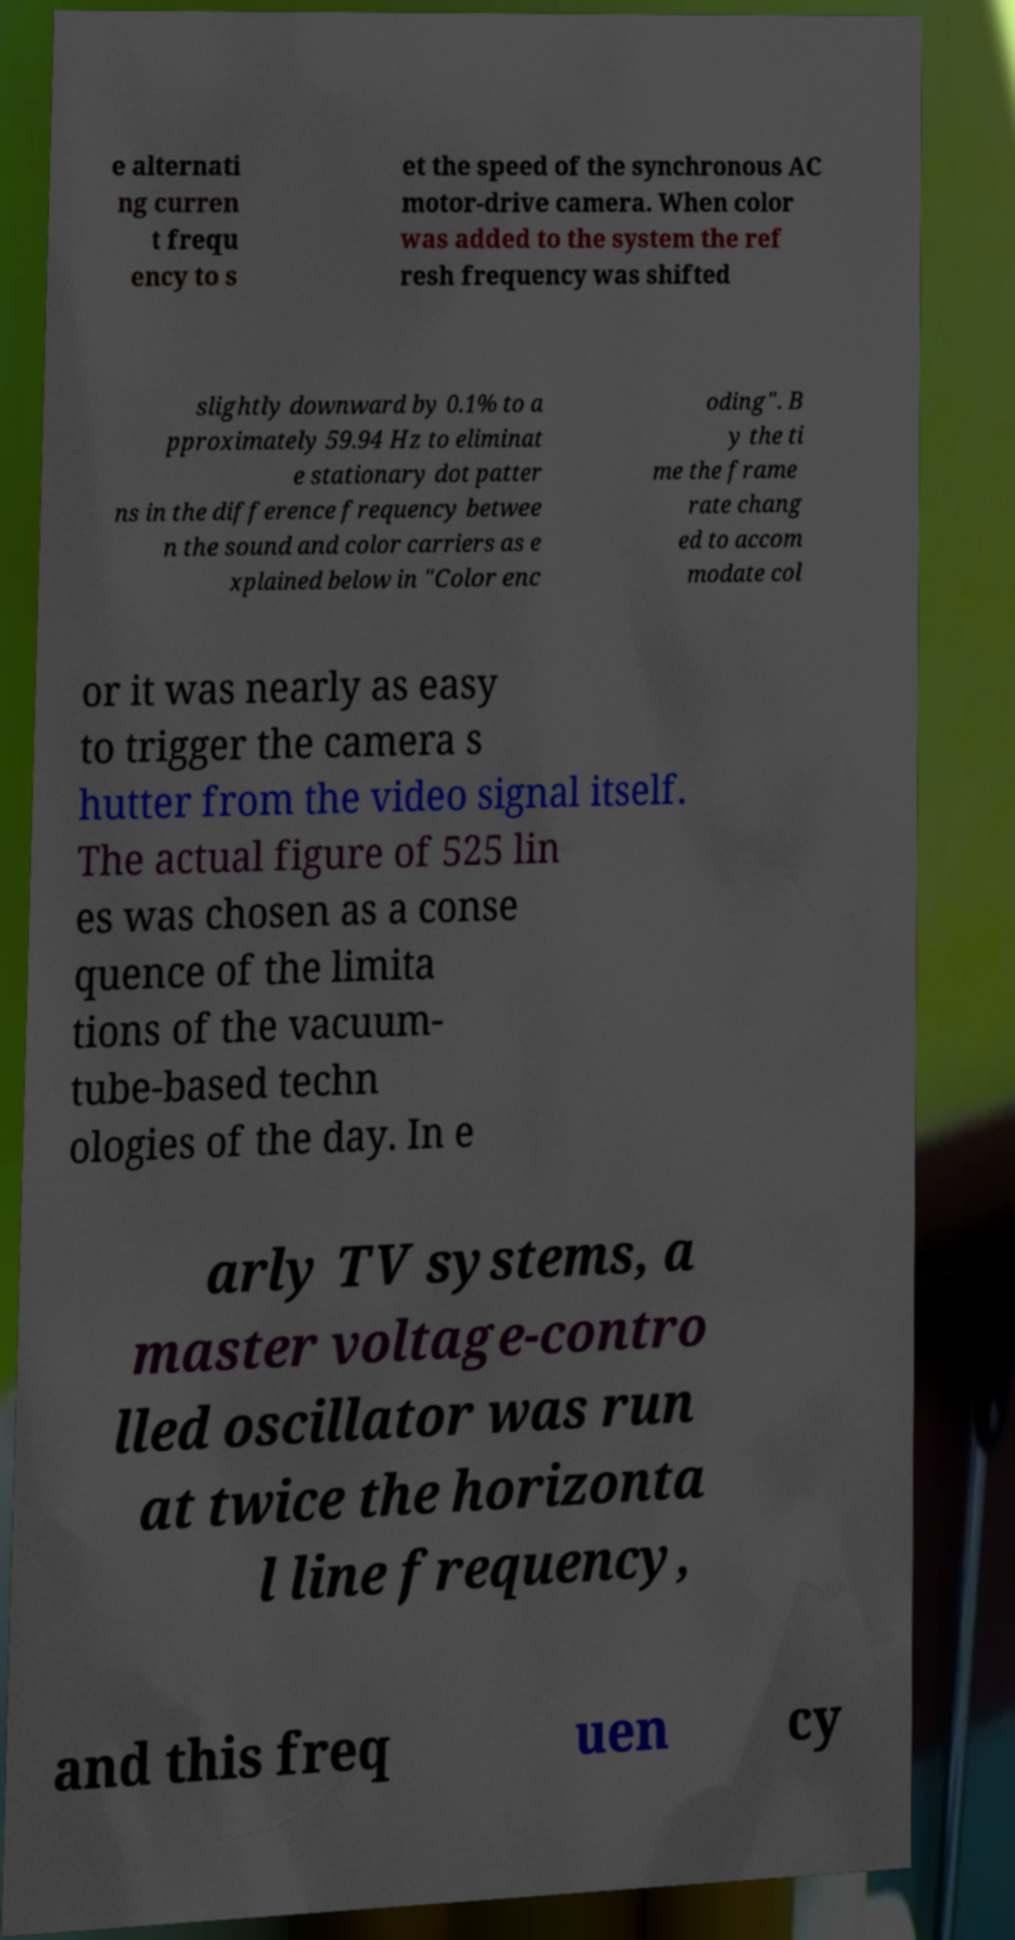Can you read and provide the text displayed in the image?This photo seems to have some interesting text. Can you extract and type it out for me? e alternati ng curren t frequ ency to s et the speed of the synchronous AC motor-drive camera. When color was added to the system the ref resh frequency was shifted slightly downward by 0.1% to a pproximately 59.94 Hz to eliminat e stationary dot patter ns in the difference frequency betwee n the sound and color carriers as e xplained below in "Color enc oding". B y the ti me the frame rate chang ed to accom modate col or it was nearly as easy to trigger the camera s hutter from the video signal itself. The actual figure of 525 lin es was chosen as a conse quence of the limita tions of the vacuum- tube-based techn ologies of the day. In e arly TV systems, a master voltage-contro lled oscillator was run at twice the horizonta l line frequency, and this freq uen cy 